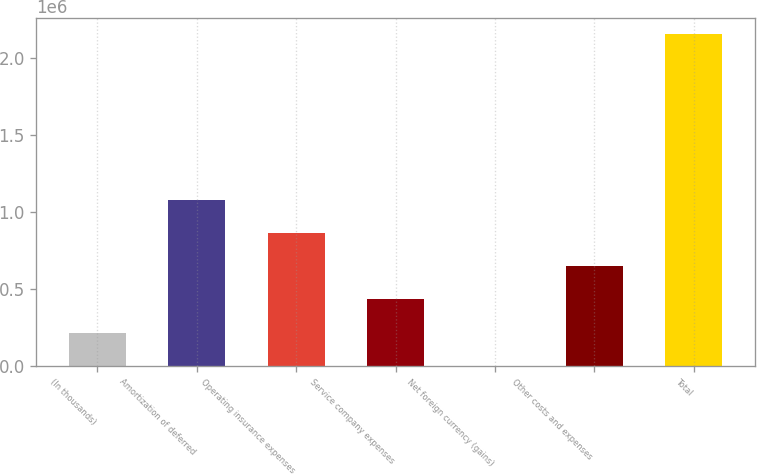Convert chart to OTSL. <chart><loc_0><loc_0><loc_500><loc_500><bar_chart><fcel>(In thousands)<fcel>Amortization of deferred<fcel>Operating insurance expenses<fcel>Service company expenses<fcel>Net foreign currency (gains)<fcel>Other costs and expenses<fcel>Total<nl><fcel>215770<fcel>1.07874e+06<fcel>862999<fcel>431513<fcel>27<fcel>647256<fcel>2.15746e+06<nl></chart> 